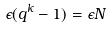Convert formula to latex. <formula><loc_0><loc_0><loc_500><loc_500>\epsilon ( q ^ { k } - 1 ) = \epsilon N</formula> 